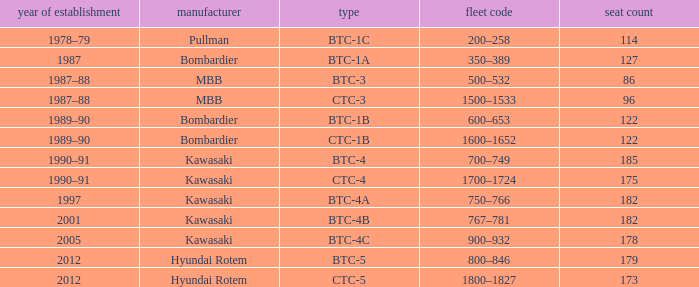Which model has 175 seats? CTC-4. 